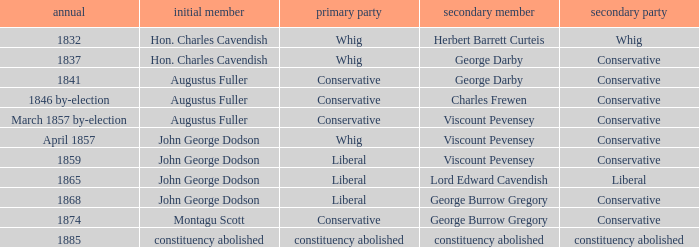In 1865, what was the first party? Liberal. 